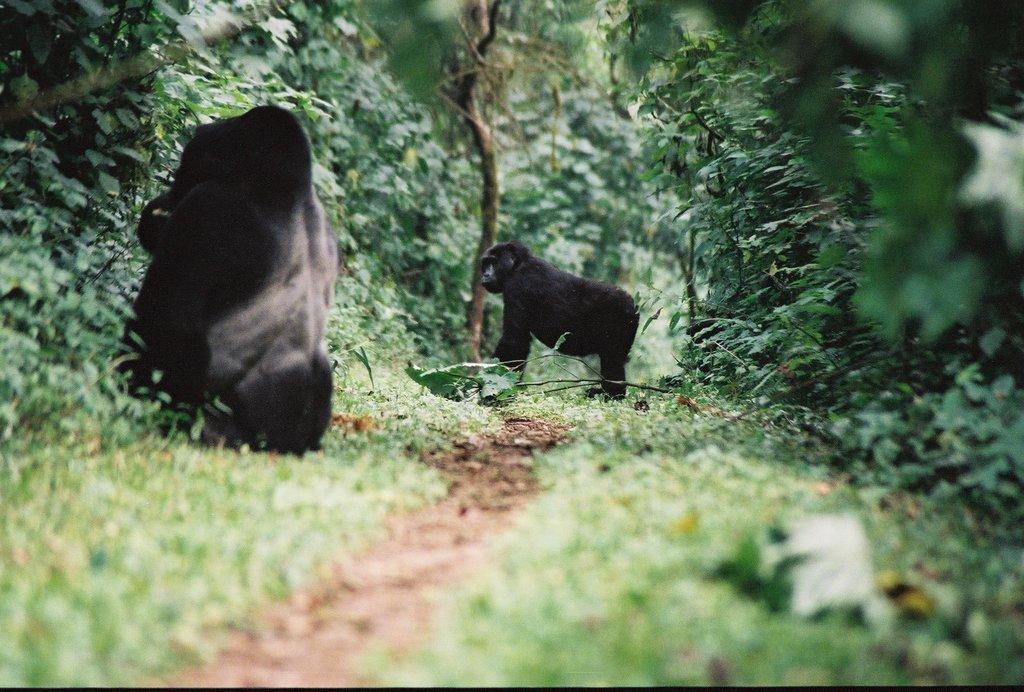How many monkeys are present in the image? There are two monkeys in the image. What can be seen in the background of the image? There is a path in the image, with trees and plants on both sides. What type of vegetation is present along the path? Trees and plants are present on both sides of the path. What type of quilt is being used as a background for the monkeys in the image? There is no quilt present in the image; it features a natural setting with a path, trees, and plants. How many ladybugs can be seen on the monkeys in the image? There are no ladybugs present in the image; it features two monkeys in a natural setting. 